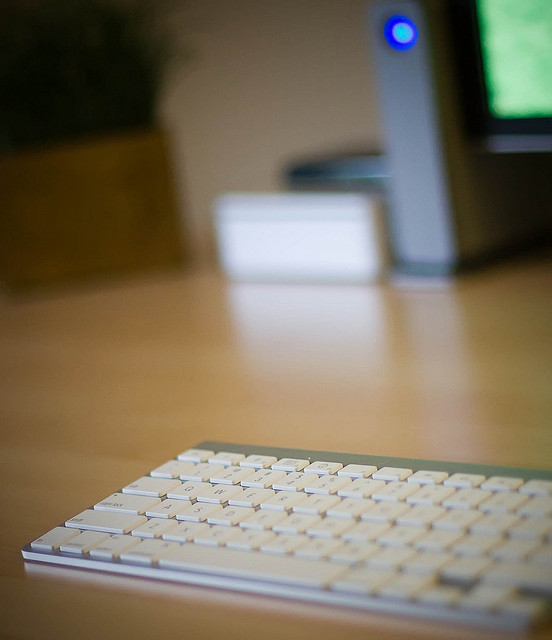<image>What is the remote pointing towards? There is no remote in the image. What is the remote pointing towards? The remote is pointing towards the screen. 